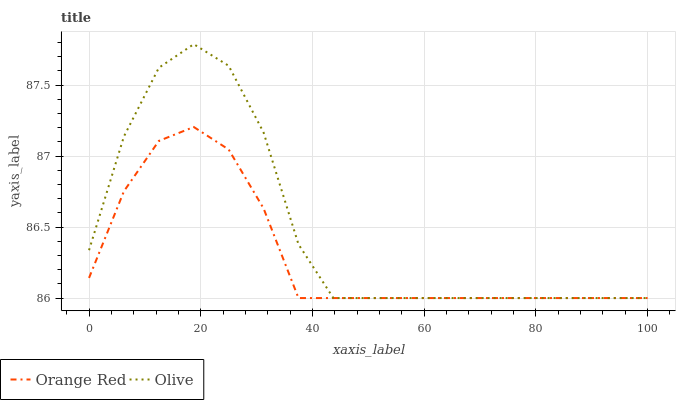Does Orange Red have the minimum area under the curve?
Answer yes or no. Yes. Does Olive have the maximum area under the curve?
Answer yes or no. Yes. Does Orange Red have the maximum area under the curve?
Answer yes or no. No. Is Orange Red the smoothest?
Answer yes or no. Yes. Is Olive the roughest?
Answer yes or no. Yes. Is Orange Red the roughest?
Answer yes or no. No. Does Olive have the lowest value?
Answer yes or no. Yes. Does Olive have the highest value?
Answer yes or no. Yes. Does Orange Red have the highest value?
Answer yes or no. No. Does Olive intersect Orange Red?
Answer yes or no. Yes. Is Olive less than Orange Red?
Answer yes or no. No. Is Olive greater than Orange Red?
Answer yes or no. No. 